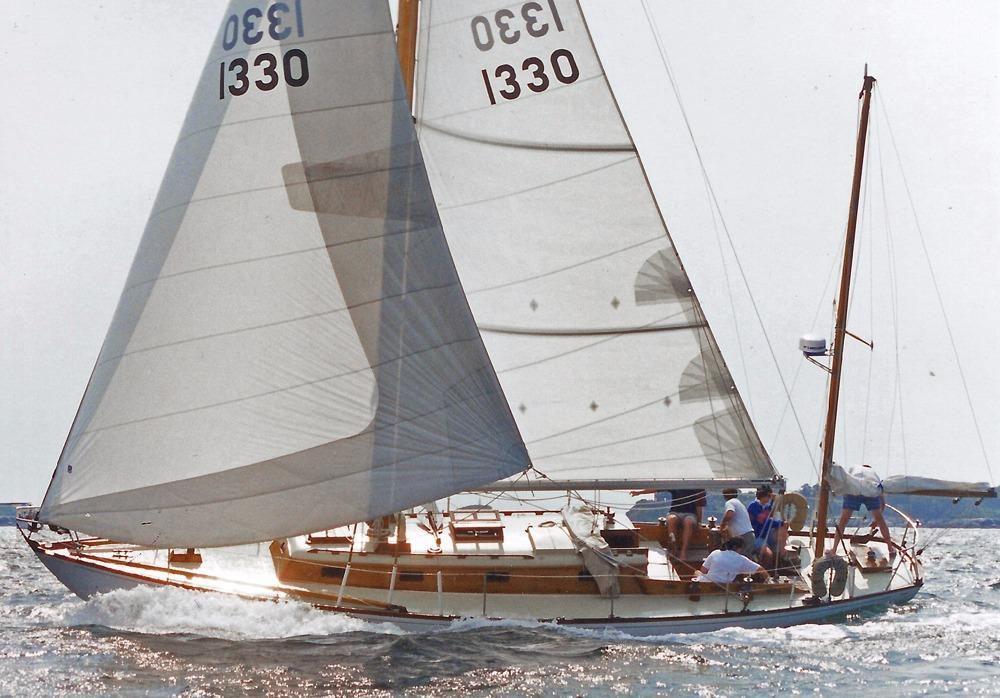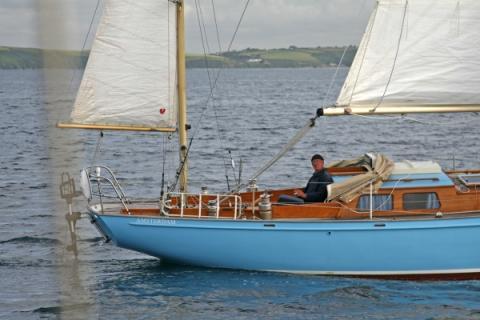The first image is the image on the left, the second image is the image on the right. Considering the images on both sides, is "There are exactly four visible sails in the image on the left." valid? Answer yes or no. No. 